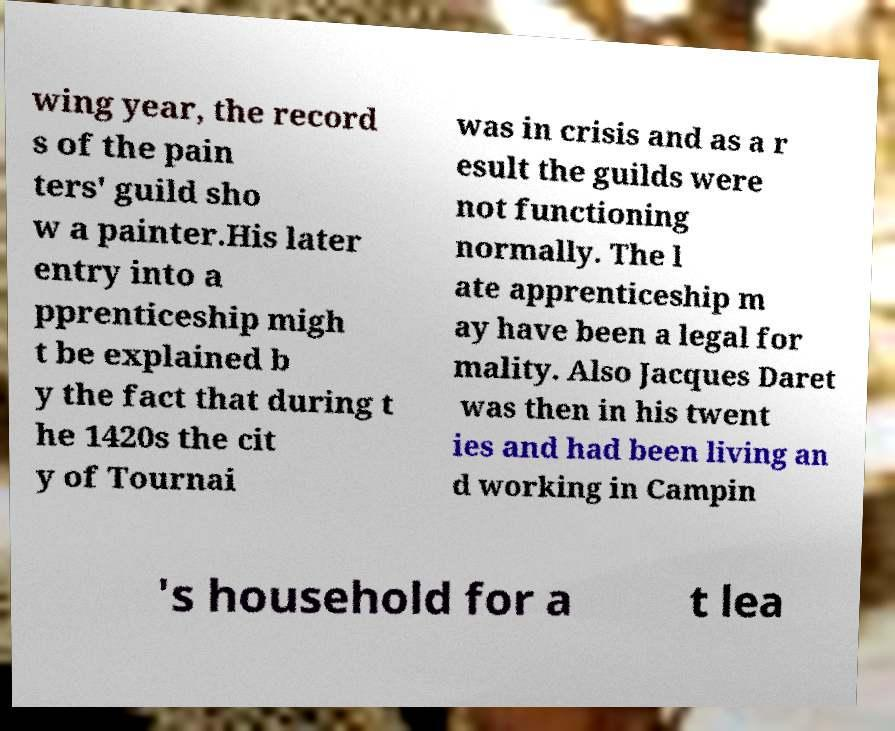Please read and relay the text visible in this image. What does it say? wing year, the record s of the pain ters' guild sho w a painter.His later entry into a pprenticeship migh t be explained b y the fact that during t he 1420s the cit y of Tournai was in crisis and as a r esult the guilds were not functioning normally. The l ate apprenticeship m ay have been a legal for mality. Also Jacques Daret was then in his twent ies and had been living an d working in Campin 's household for a t lea 